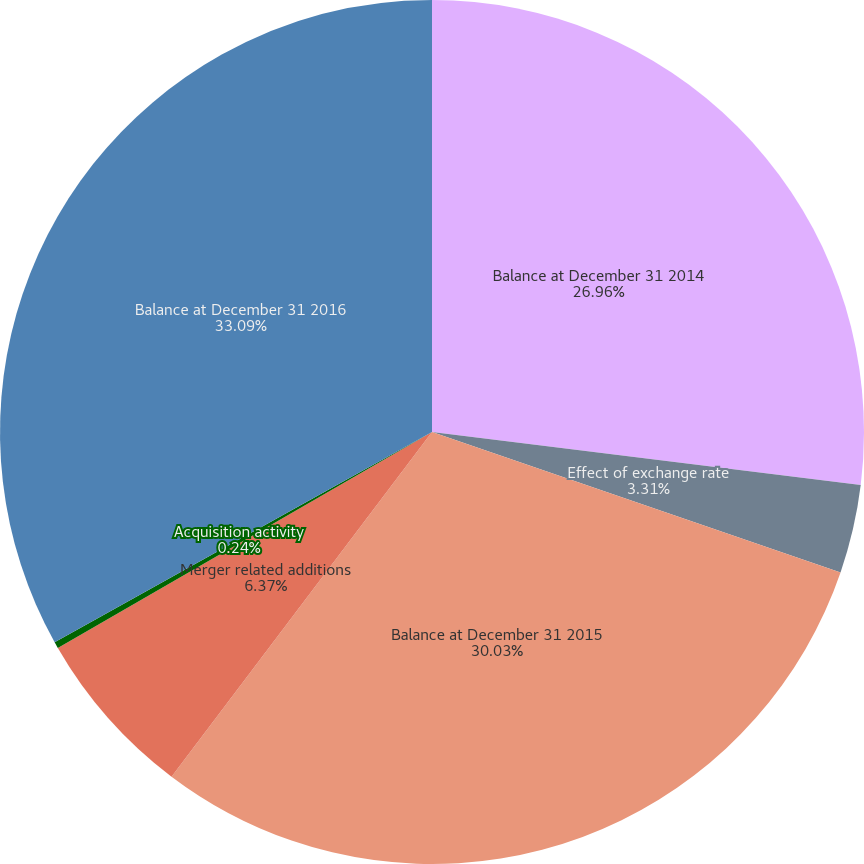Convert chart. <chart><loc_0><loc_0><loc_500><loc_500><pie_chart><fcel>Balance at December 31 2014<fcel>Effect of exchange rate<fcel>Balance at December 31 2015<fcel>Merger related additions<fcel>Acquisition activity<fcel>Balance at December 31 2016<nl><fcel>26.96%<fcel>3.31%<fcel>30.03%<fcel>6.37%<fcel>0.24%<fcel>33.09%<nl></chart> 